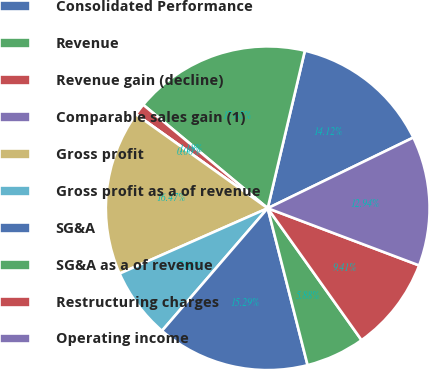Convert chart to OTSL. <chart><loc_0><loc_0><loc_500><loc_500><pie_chart><fcel>Consolidated Performance<fcel>Revenue<fcel>Revenue gain (decline)<fcel>Comparable sales gain (1)<fcel>Gross profit<fcel>Gross profit as a of revenue<fcel>SG&A<fcel>SG&A as a of revenue<fcel>Restructuring charges<fcel>Operating income<nl><fcel>14.12%<fcel>17.65%<fcel>1.18%<fcel>0.0%<fcel>16.47%<fcel>7.06%<fcel>15.29%<fcel>5.88%<fcel>9.41%<fcel>12.94%<nl></chart> 